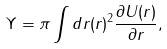<formula> <loc_0><loc_0><loc_500><loc_500>\Upsilon = \pi \int d r ( r ) ^ { 2 } \frac { \partial U ( r ) } { \partial r } ,</formula> 